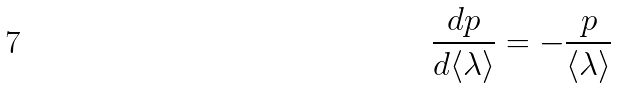Convert formula to latex. <formula><loc_0><loc_0><loc_500><loc_500>\frac { d p } { d \langle { \lambda } \rangle } = - \frac { p } { \langle { \lambda } \rangle }</formula> 